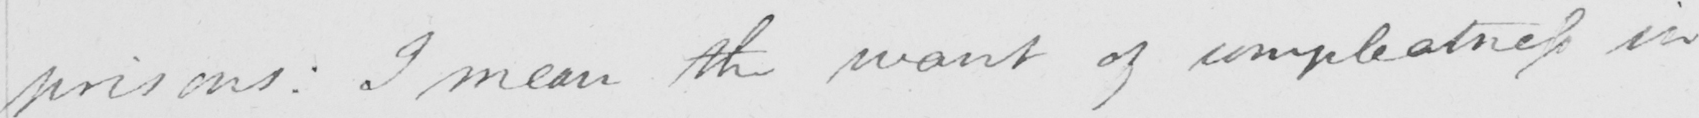Transcribe the text shown in this historical manuscript line. prisons :  I mean the want of compleatness in 